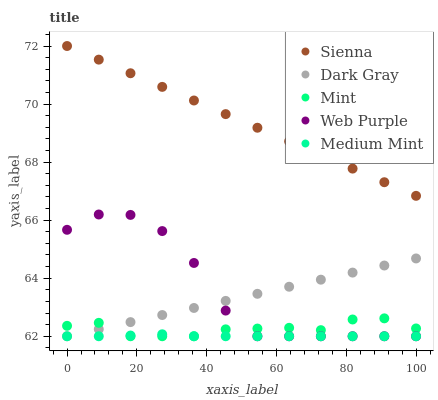Does Medium Mint have the minimum area under the curve?
Answer yes or no. Yes. Does Sienna have the maximum area under the curve?
Answer yes or no. Yes. Does Dark Gray have the minimum area under the curve?
Answer yes or no. No. Does Dark Gray have the maximum area under the curve?
Answer yes or no. No. Is Dark Gray the smoothest?
Answer yes or no. Yes. Is Web Purple the roughest?
Answer yes or no. Yes. Is Web Purple the smoothest?
Answer yes or no. No. Is Dark Gray the roughest?
Answer yes or no. No. Does Dark Gray have the lowest value?
Answer yes or no. Yes. Does Sienna have the highest value?
Answer yes or no. Yes. Does Dark Gray have the highest value?
Answer yes or no. No. Is Medium Mint less than Sienna?
Answer yes or no. Yes. Is Sienna greater than Mint?
Answer yes or no. Yes. Does Dark Gray intersect Mint?
Answer yes or no. Yes. Is Dark Gray less than Mint?
Answer yes or no. No. Is Dark Gray greater than Mint?
Answer yes or no. No. Does Medium Mint intersect Sienna?
Answer yes or no. No. 